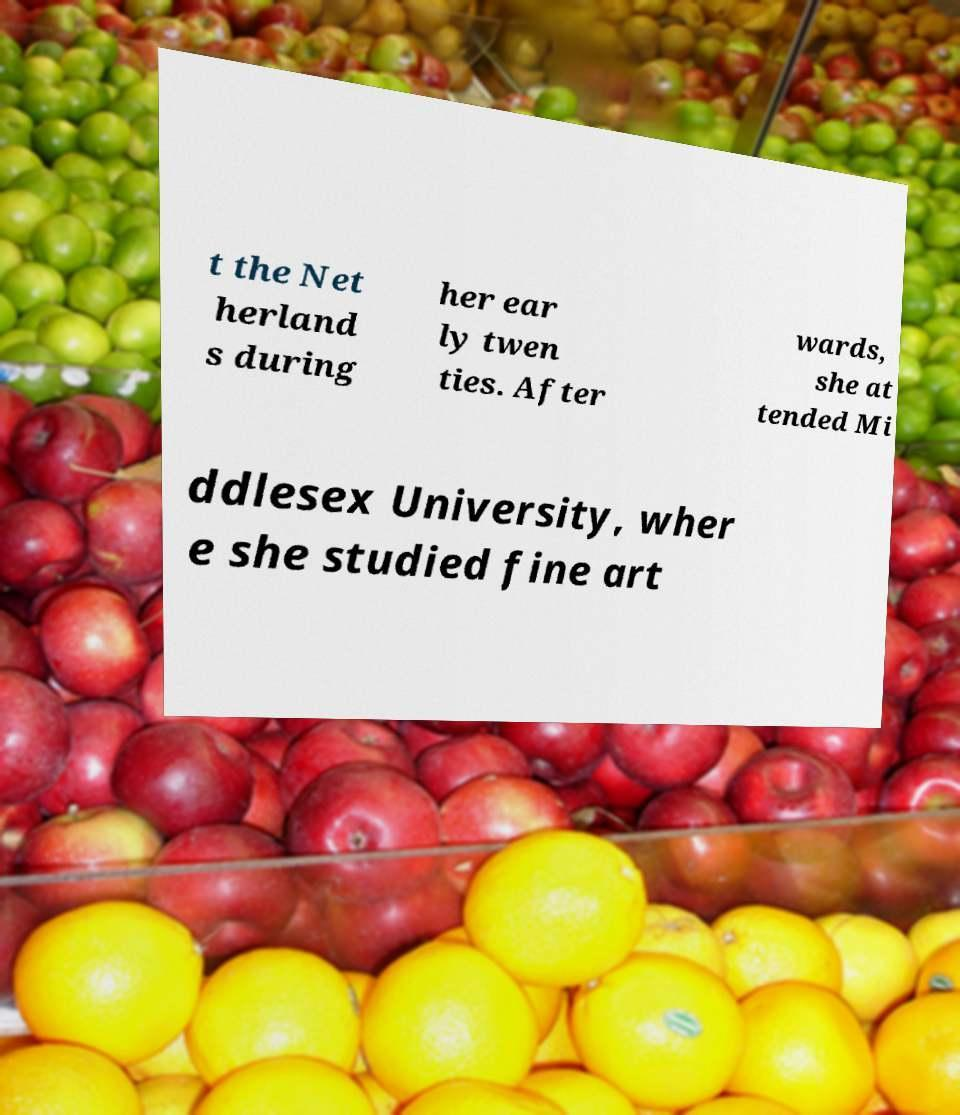There's text embedded in this image that I need extracted. Can you transcribe it verbatim? t the Net herland s during her ear ly twen ties. After wards, she at tended Mi ddlesex University, wher e she studied fine art 